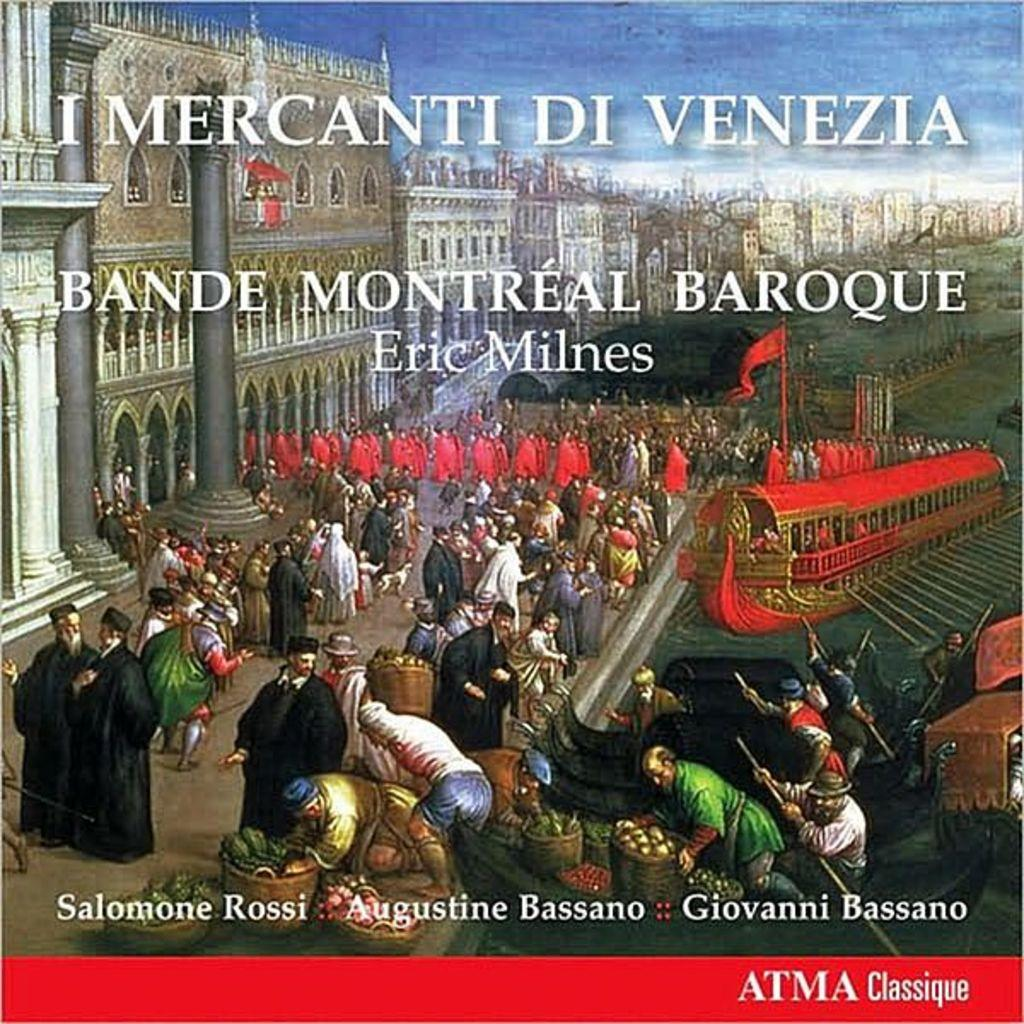<image>
Provide a brief description of the given image. Imercanti de venezia Atma classique booklet with people on the front cover 